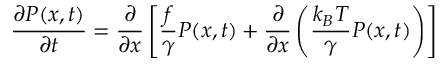<formula> <loc_0><loc_0><loc_500><loc_500>{ \frac { \partial P ( x , t ) } { \partial t } } = { \frac { \partial } { \partial x } } \left [ { \frac { f } { \gamma } } P ( x , t ) + { \frac { \partial } { \partial x } } \left ( { \frac { k _ { B } T } { \gamma } } P ( x , t ) \right ) \right ]</formula> 